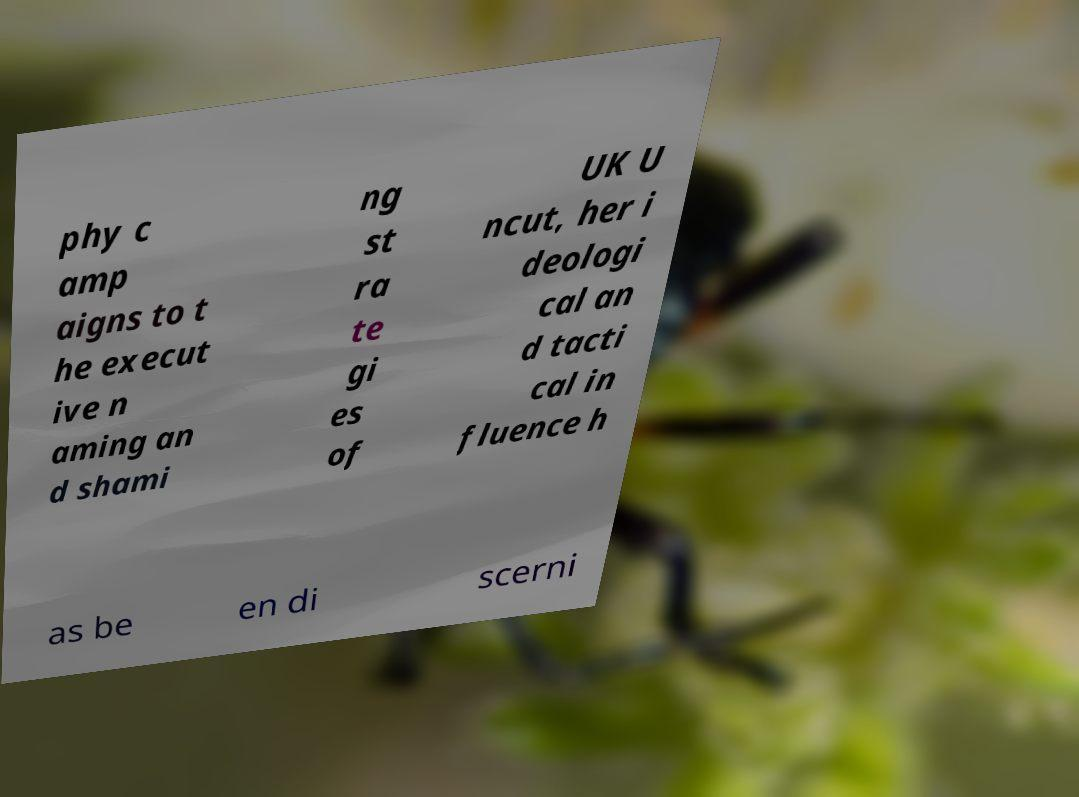What messages or text are displayed in this image? I need them in a readable, typed format. phy c amp aigns to t he execut ive n aming an d shami ng st ra te gi es of UK U ncut, her i deologi cal an d tacti cal in fluence h as be en di scerni 